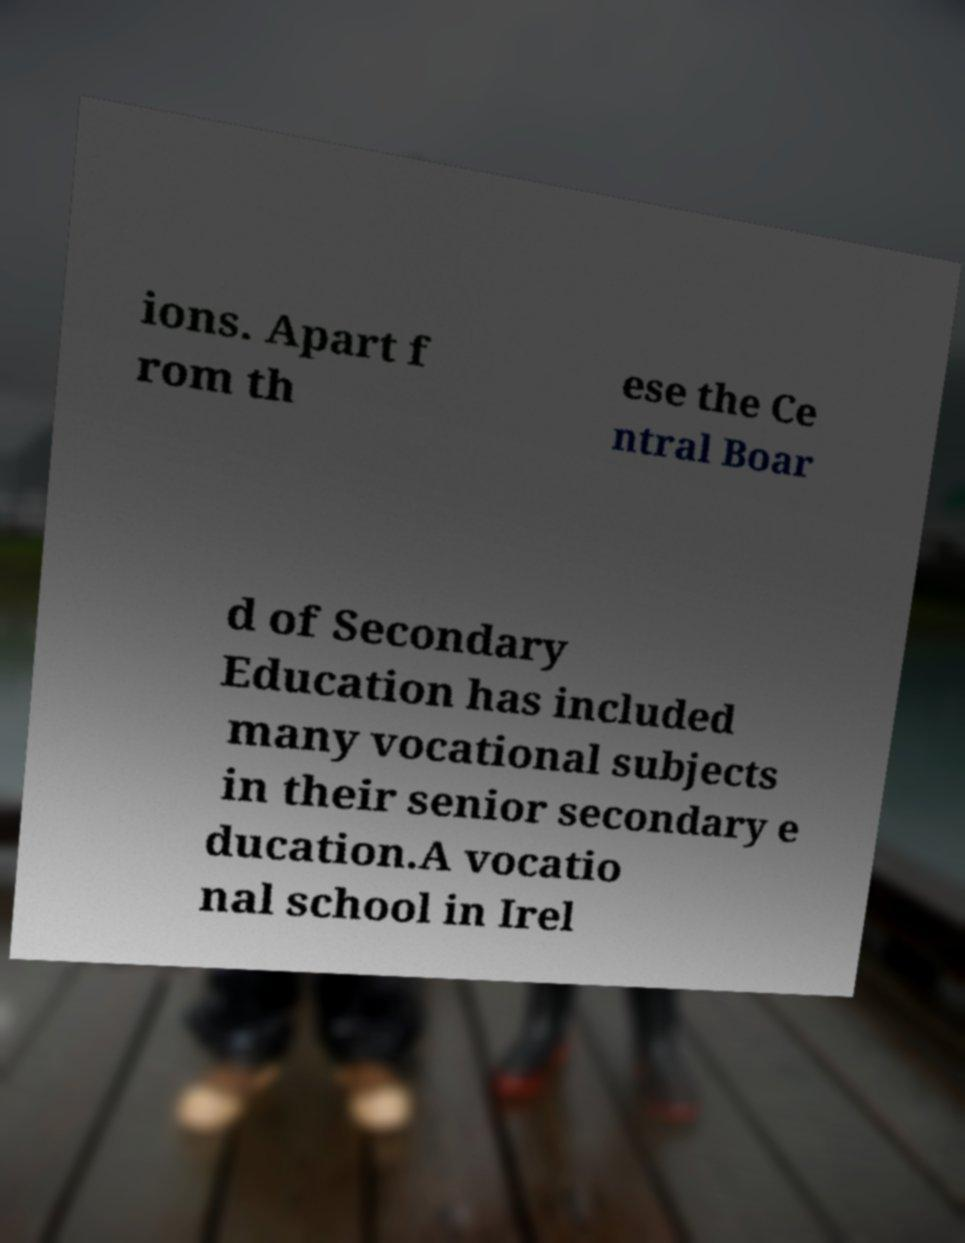There's text embedded in this image that I need extracted. Can you transcribe it verbatim? ions. Apart f rom th ese the Ce ntral Boar d of Secondary Education has included many vocational subjects in their senior secondary e ducation.A vocatio nal school in Irel 